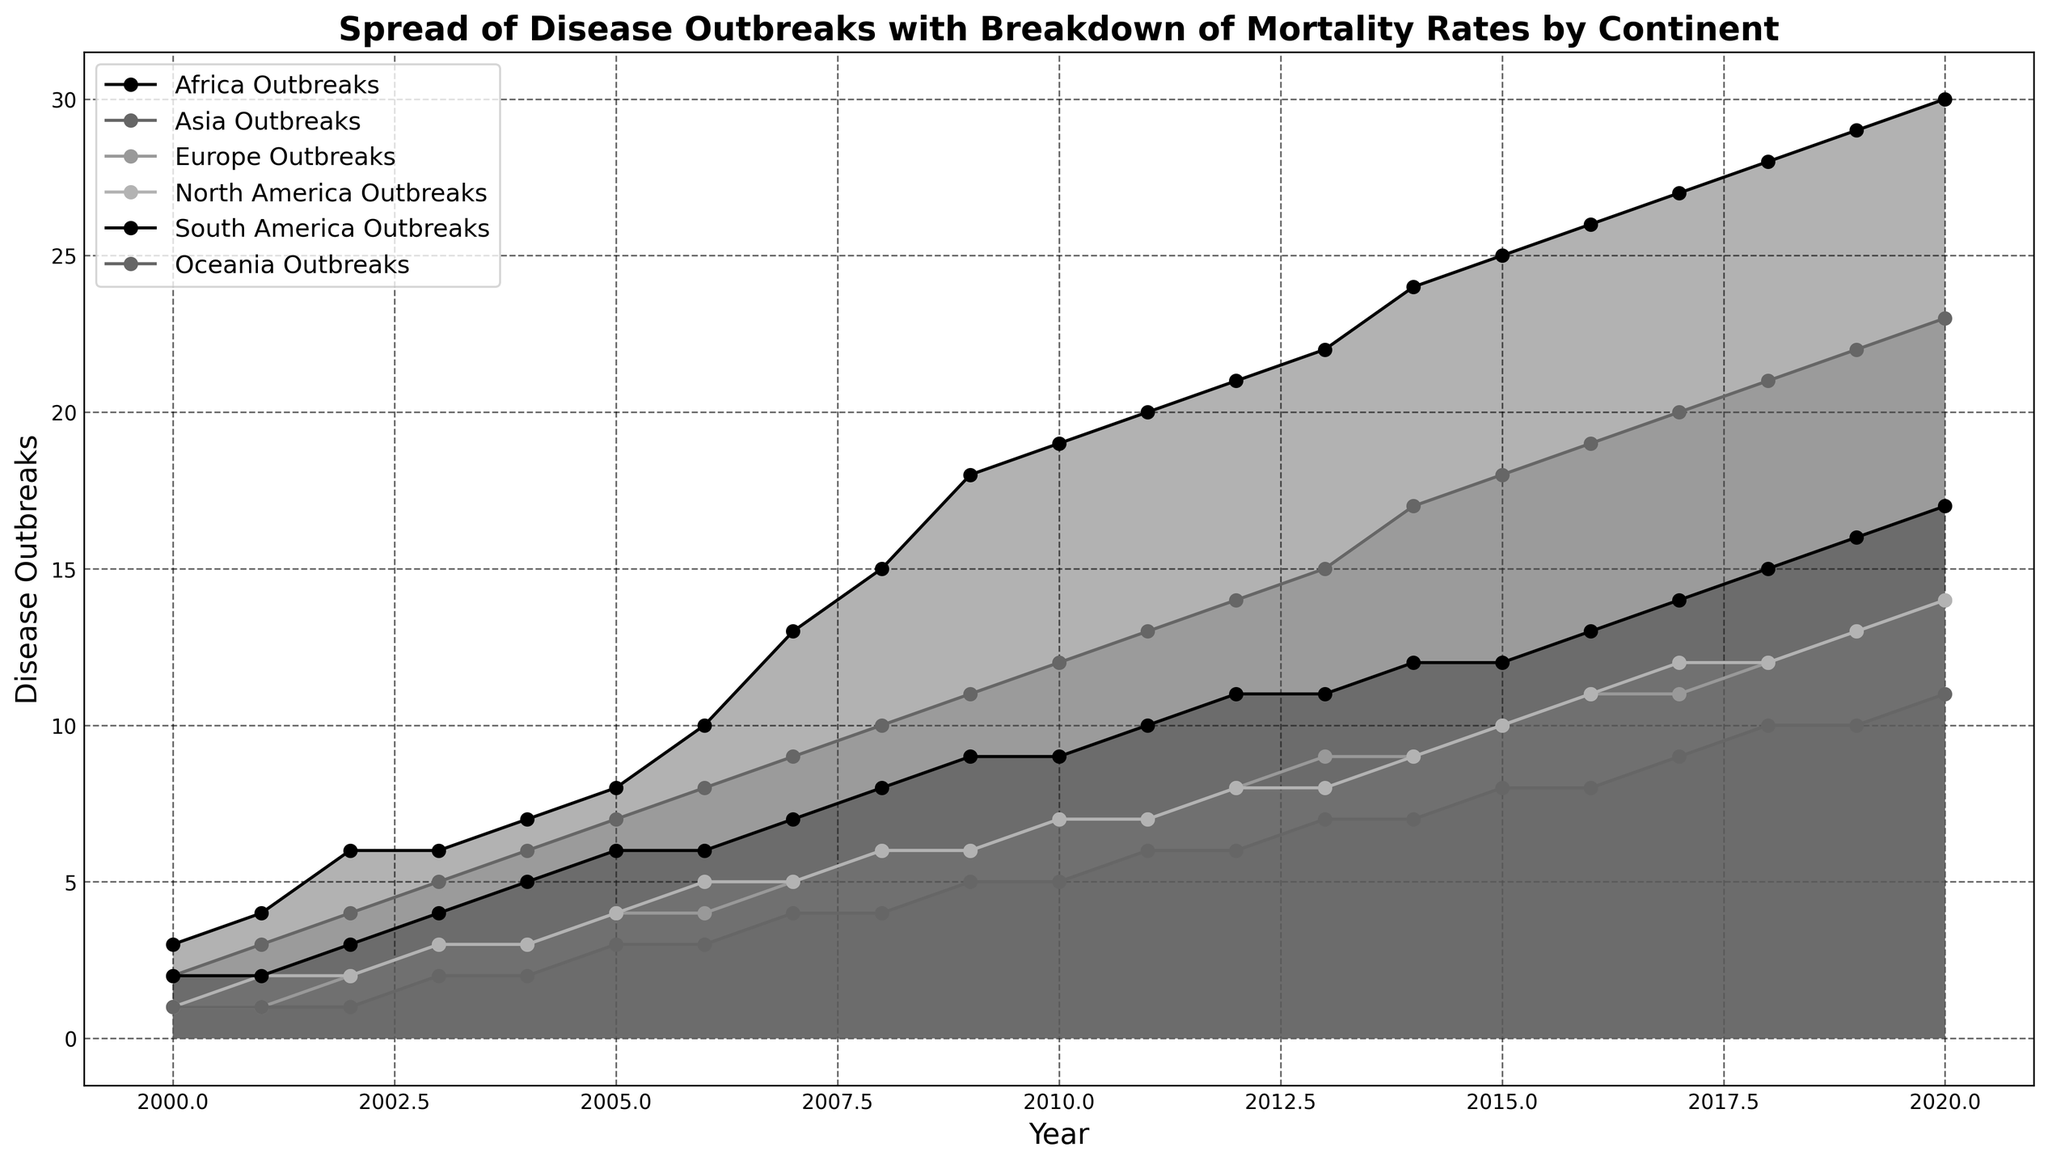Which continent had the highest number of disease outbreaks in 2020? To determine this, look at the points for 2020 on each continent's line and identify the one with the highest value. The line representing Africa shows 30 disease outbreaks in 2020, which is the highest among all continents.
Answer: Africa Which two continents had the smallest difference in disease outbreaks in 2010? To answer this, observe the number of disease outbreaks for each continent in 2010 and find the two closest values. Europe and North America both had 7 disease outbreaks, which means their difference is 0, the smallest possible.
Answer: Europe and North America How many more disease outbreaks did Africa experience compared to Asia in 2020? Find the difference in disease outbreaks between Africa and Asia in 2020. Africa had 30 and Asia had 23, so the difference is 30 - 23 = 7.
Answer: 7 Which continent witnessed a steady increase in disease outbreaks every year from 2000 to 2020? Look at the trend lines for each continent. Africa's line shows a consistent increase every year without any dips, indicating a steady rise.
Answer: Africa Which year did Asia experience the same number of disease outbreaks as Europe? Examine the lines for Asia and Europe and identify where their values match. In 2009, both continents experienced 6 disease outbreaks.
Answer: 2009 What is the average number of disease outbreaks in Oceania from 2000 to 2020? Sum the number of disease outbreaks each year for Oceania from 2000 to 2020, then divide by the number of years (21). The sum is 1 + 1 + 1 + 2 + 2 + 3 + 3 + 4 + 4 + 5 + 5 + 6 + 6 + 7 + 7 + 8 + 8 + 9 + 10 + 10 + 11 = 110. The average is 110 / 21 ≈ 5.24.
Answer: 5.24 What visual feature makes it easier to compare the trends of disease outbreaks across continents? The use of distinct lines and filled areas under the curves helps to visually separate and compare the trends of each continent.
Answer: Distinct lines and filled areas In what year did South America have more disease outbreaks than North America for the first time? Inspect the lines for South America and North America to see the first intersection point. This occurs in 2005 when South America had 6 outbreaks and North America had 4.
Answer: 2005 Which continent shows the least variation in disease outbreaks from 2000 to 2020? Compare the range (difference between maximum and minimum values) of disease outbreaks for each continent. Oceania has the least variation with a range of 11-1 = 10.
Answer: Oceania 